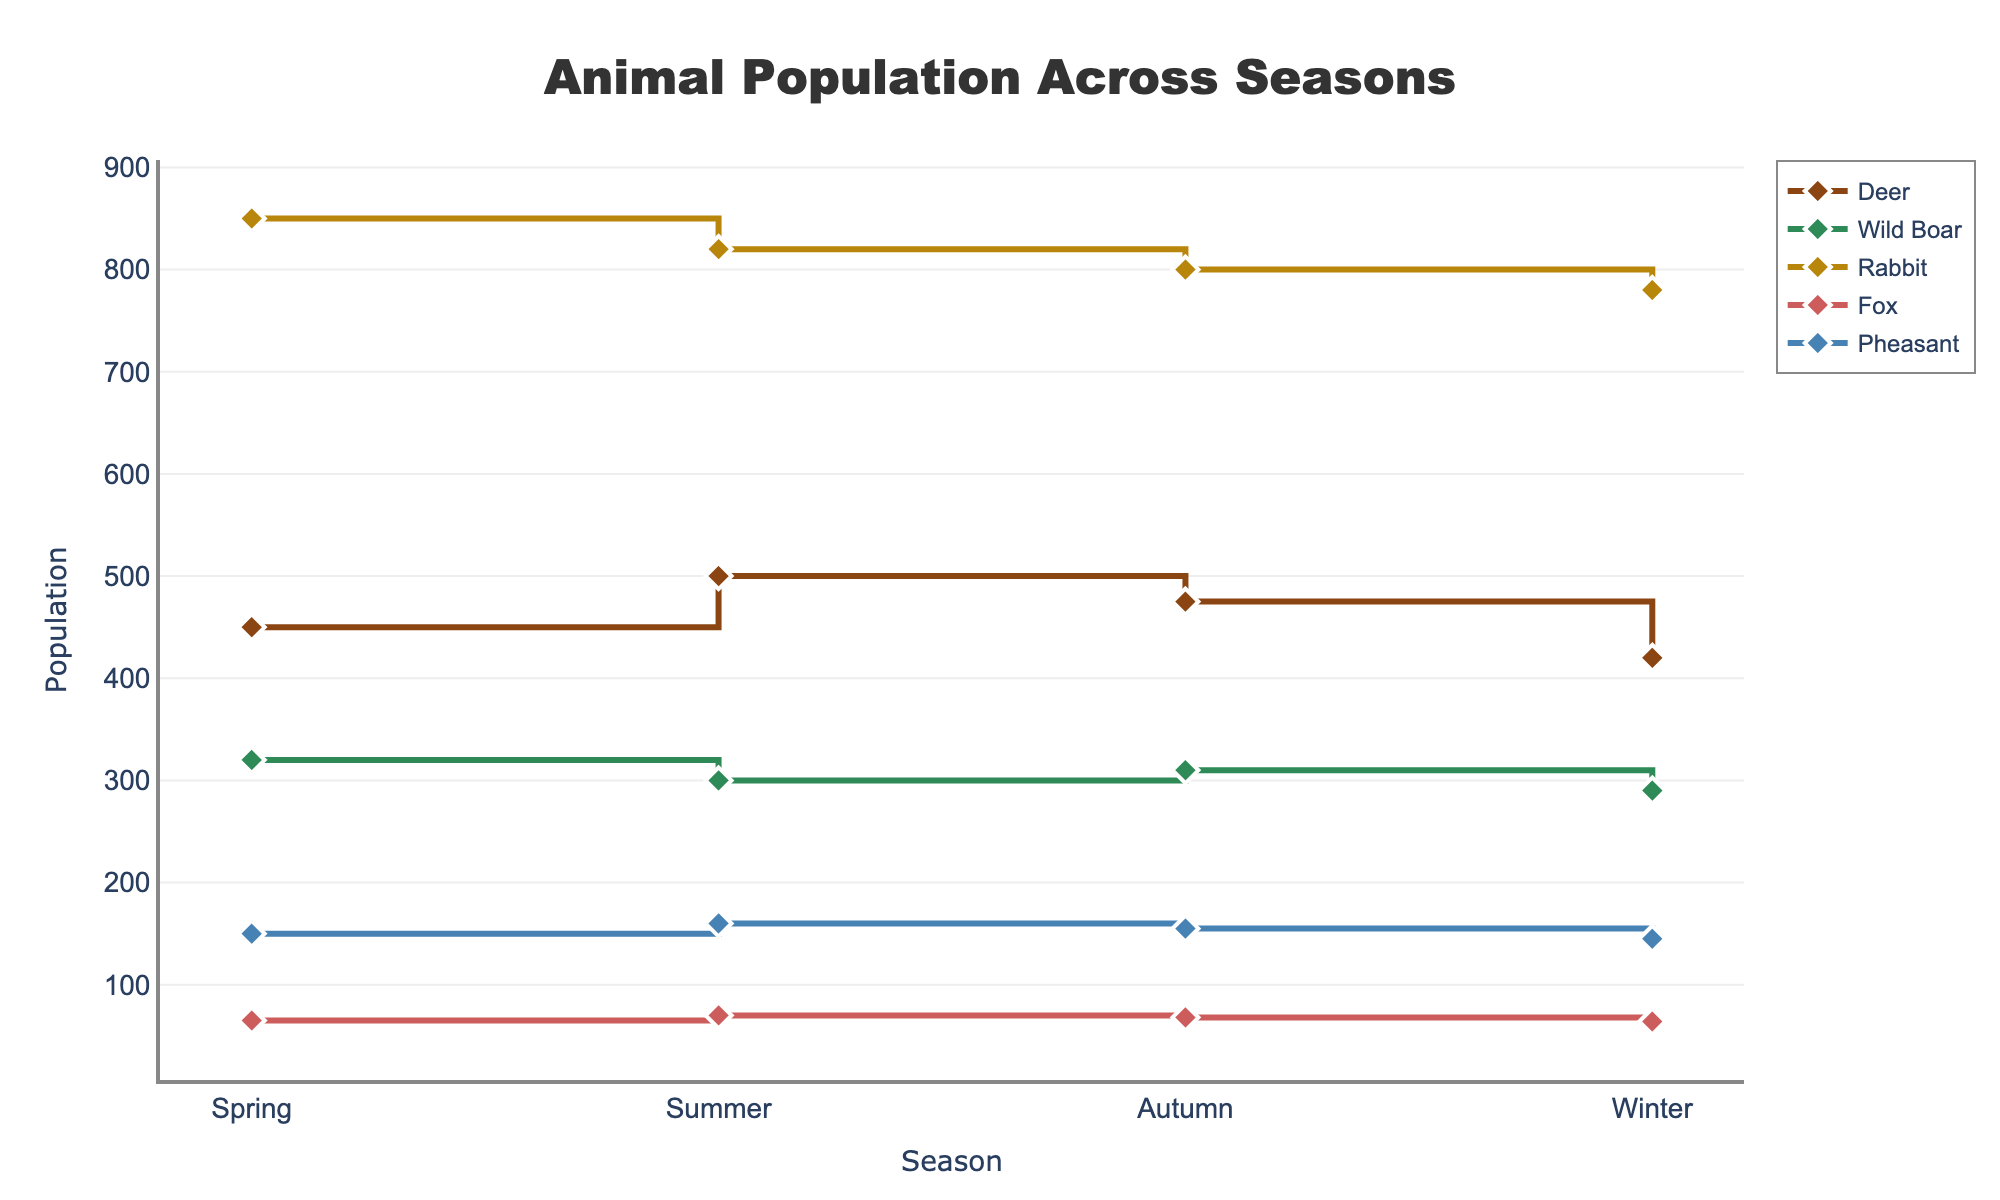What is the title of the plot? The title is usually at the top of the figure and it summarizes the main subject of the plot.
Answer: Animal Population Across Seasons Which animal has the highest population in Spring? By looking at the Spring column in the plot, the animal with the highest point is identified.
Answer: Rabbit How does the population of Deer change from Summer to Winter? Look at the population values for Deer between Summer and Winter; the values decrease from 500 in Summer to 420 in Winter.
Answer: It decreases Which season has the lowest population of Wild Boar? Look at the points for Wild Boar in all seasons and identify the lowest point; it is in Winter with a population of 290.
Answer: Winter What is the sum of the Pheasant population across all seasons? Add the population values for Pheasant across Spring, Summer, Autumn, and Winter: 150 + 160 + 155 + 145 = 610.
Answer: 610 Which two animals have the closest population values in Autumn? Compare the Autumn population values for all species; Wild Boar (310) and Fox (68). The closest pair is Fox and Wild Boar.
Answer: Wild Boar and Fox What is the average population of Fox across the four seasons? Add the population values for Fox across all seasons and divide by 4: (65 + 70 + 68 + 64) / 4 = 67.
Answer: 67 Is there any animal whose population remained stable across the seasons? Look at the population trends for all animals. No animal has the exact same population in all seasons.
Answer: No By how much does Rabbit population decrease from Spring to Winter? Subtract the Winter population from Spring for Rabbit: 850 - 780 = 70.
Answer: 70 Which animal's population shows the most variability across seasons? Compare the range (difference between the highest and lowest values) for each animal's population. Deer shows the largest fluctuation from 500 to 420, a range of 80.
Answer: Deer 